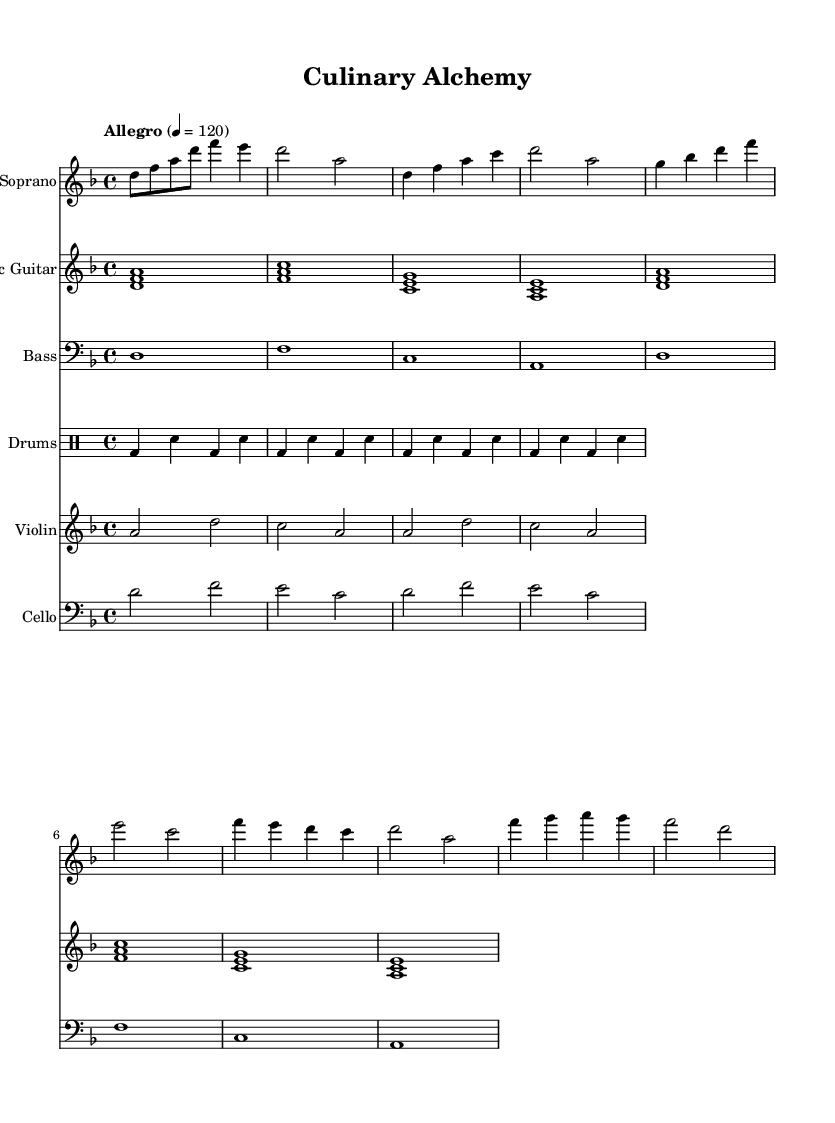What is the key signature of this music? The key signature is indicated at the beginning of the staff, where a single flat appears, meaning it is D minor.
Answer: D minor What is the time signature of this music? The time signature is located at the beginning of the score, and it indicates that there are four beats per measure, so it is in four-four time.
Answer: 4/4 What is the tempo marking for this music? The tempo is given at the start and specifies "Allegro," along with a metronome marking of 120 beats per minute.
Answer: Allegro How many measures are in the Intro section? By counting the number of vertical lines in the notation, which represent bar lines, we see there are four measures in the Intro section.
Answer: 4 What instrument plays the intro notes composed of three notes? The instrument that plays the intro notes is the Electric Guitar, as indicated in the staff label and the array of pitches written for it.
Answer: Electric Guitar In the Chorus, what is the first note sung by the soprano? Looking at the first note of the Chorus for the Soprano part reveals that it is the note F.
Answer: F How do the lyrics in the verse relate to the theme of cooking? The lyrics in the verse reference "a crucible of change," suggesting that cooking transforms ingredients into meals, closely connecting to the theme of cooking.
Answer: Transformation 